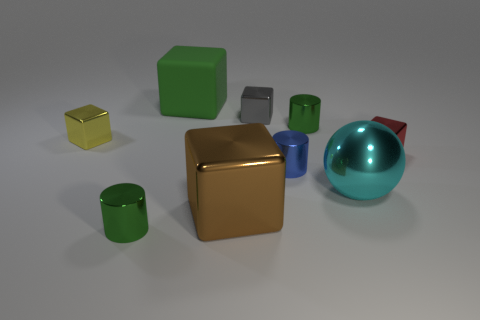Can you tell me which objects are reflective? Certainly, the objects that appear reflective are the silver cube, the green and silver cylinders, and the large blue sphere. They display clear reflections on their surfaces. 